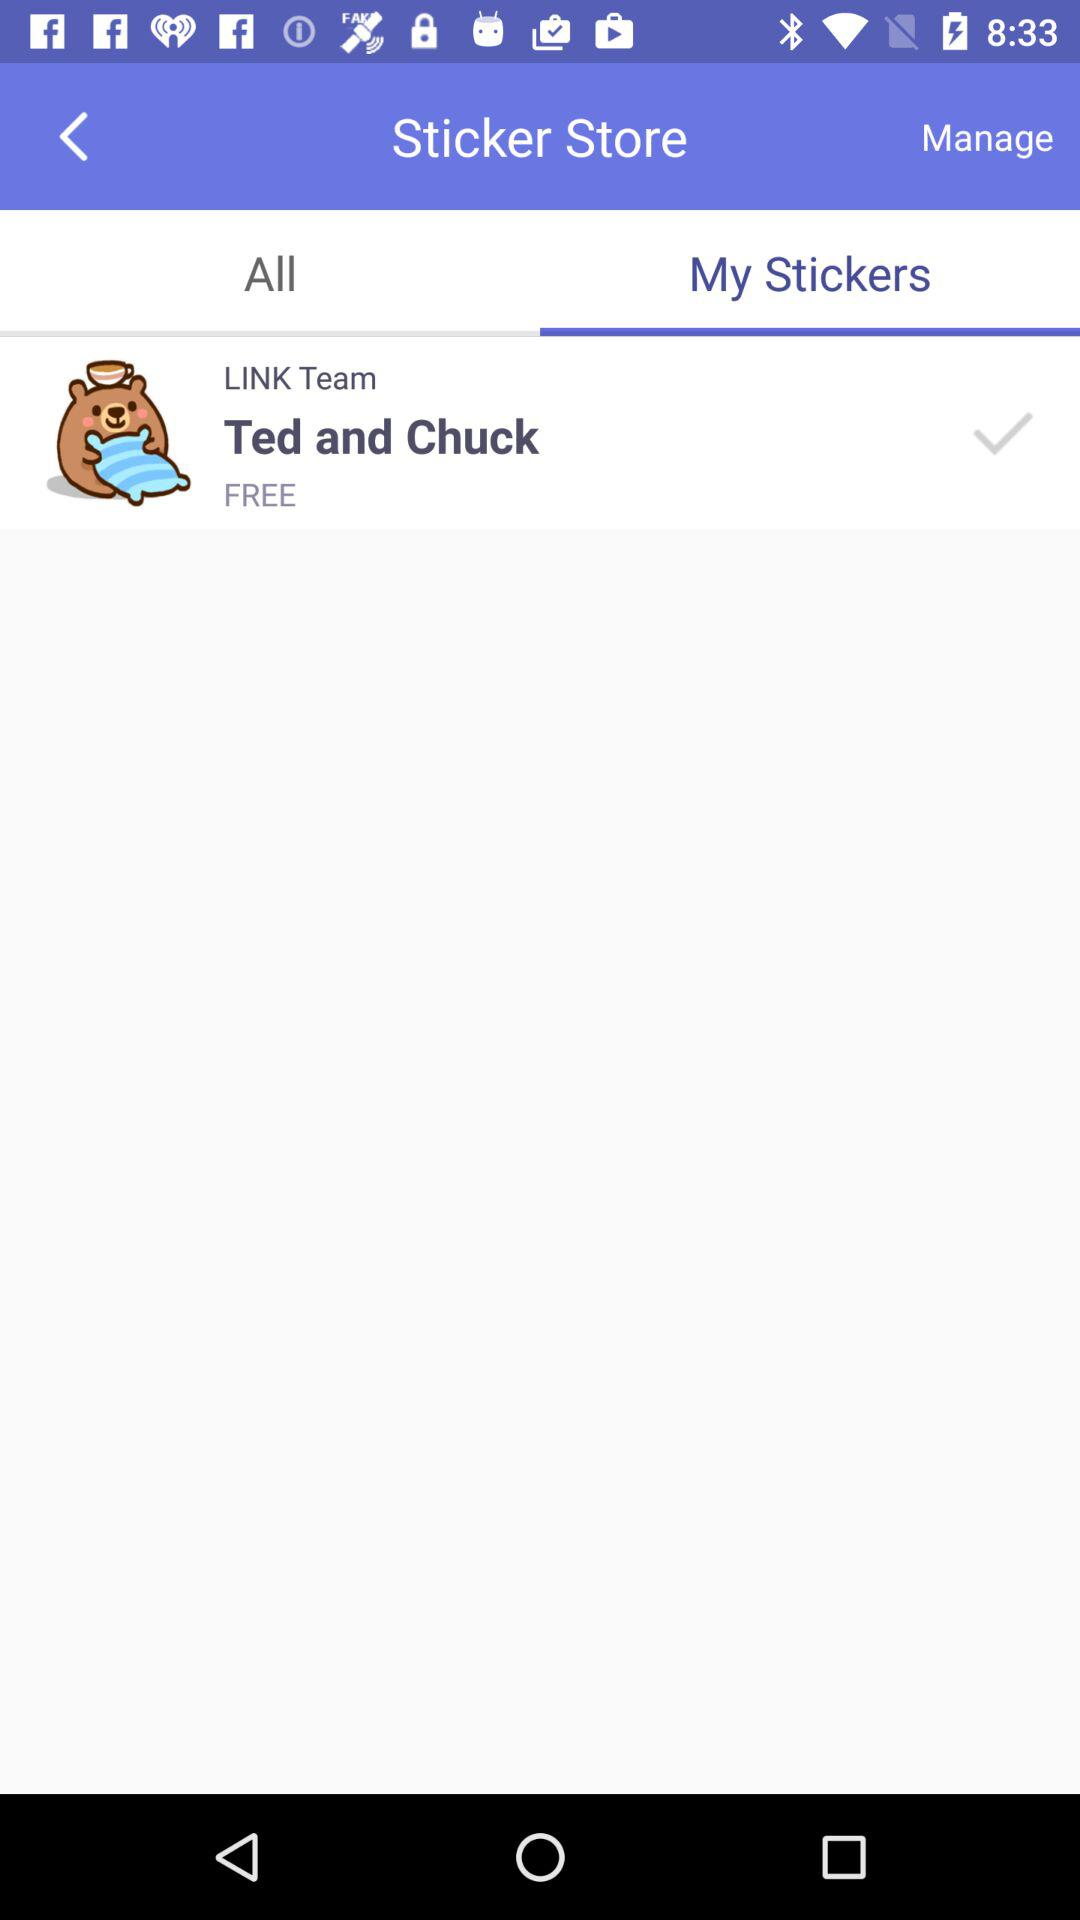How much do I have to pay to use the Ted and Chuck sticker? You can use it for free. 